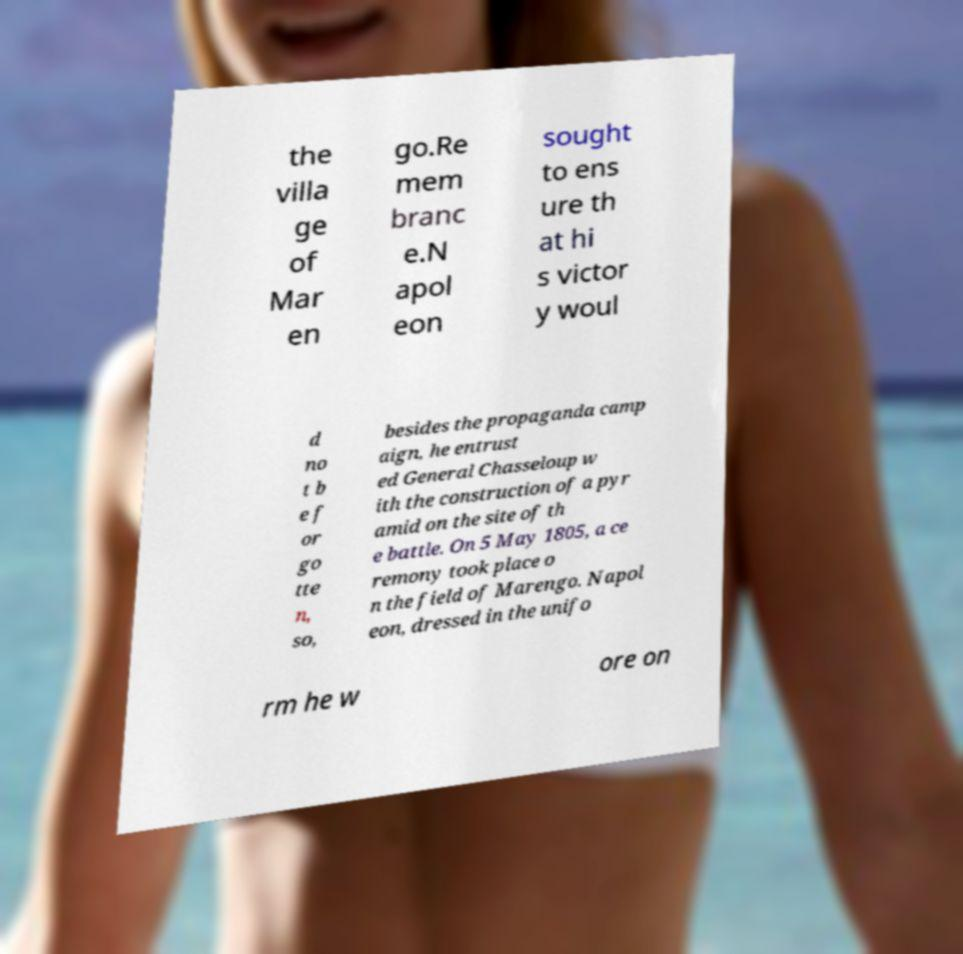Please identify and transcribe the text found in this image. the villa ge of Mar en go.Re mem branc e.N apol eon sought to ens ure th at hi s victor y woul d no t b e f or go tte n, so, besides the propaganda camp aign, he entrust ed General Chasseloup w ith the construction of a pyr amid on the site of th e battle. On 5 May 1805, a ce remony took place o n the field of Marengo. Napol eon, dressed in the unifo rm he w ore on 